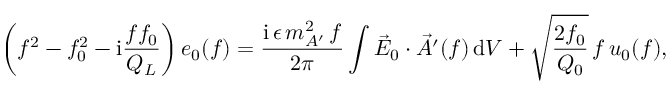Convert formula to latex. <formula><loc_0><loc_0><loc_500><loc_500>\left ( f ^ { 2 } - f _ { 0 } ^ { 2 } - i \frac { f f _ { 0 } } { Q _ { L } } \right ) e _ { 0 } ( f ) = \frac { i \, \epsilon \, m _ { A ^ { \prime } } ^ { 2 } \, f } { 2 \pi } \int \vec { E } _ { 0 } \cdot \vec { A ^ { \prime } } ( f ) \, d V + \sqrt { \frac { 2 f _ { 0 } } { Q _ { 0 } } } \, f \, { u } _ { 0 } ( f ) ,</formula> 